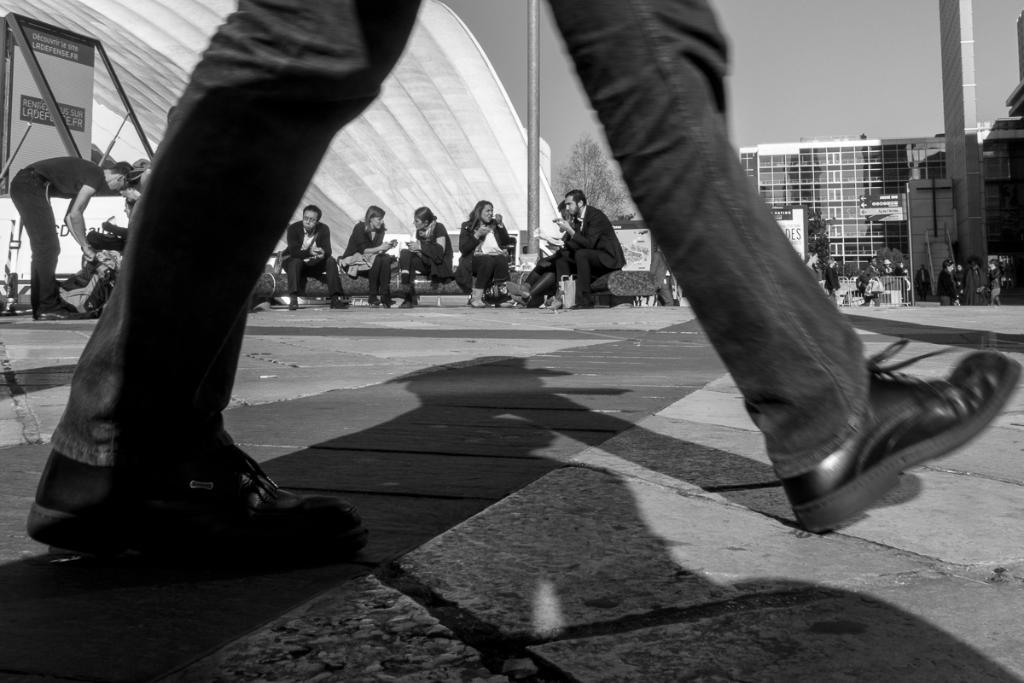What is the color scheme of the image? The image is black and white. What can be seen in the image besides the color scheme? There is a group of people and buildings in the image. Are there any natural elements present in the image? Yes, there is a tree in the image. What is visible in the background of the image? The sky is visible in the background of the image. What type of cushion is being used by the people in the image? There is no cushion present in the image. What direction are the people sailing in the image? There is no sailing or sailboat present in the image. 